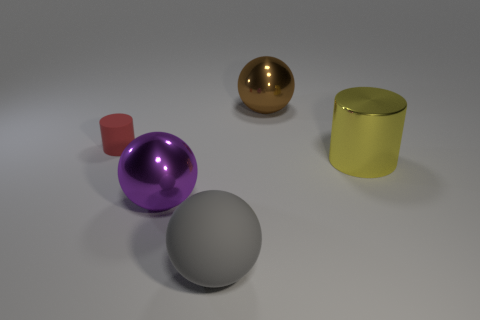What number of rubber things are either large brown objects or big blue cylinders?
Provide a succinct answer. 0. What number of objects are to the right of the purple shiny thing and behind the purple shiny ball?
Your answer should be compact. 2. Are there any other things that have the same shape as the tiny red matte object?
Your answer should be compact. Yes. How many other things are there of the same size as the brown ball?
Provide a succinct answer. 3. There is a cylinder that is right of the red matte cylinder; is it the same size as the thing that is to the left of the purple shiny sphere?
Your response must be concise. No. What number of objects are either tiny red cylinders or spheres that are in front of the red matte cylinder?
Offer a terse response. 3. How big is the metal object that is in front of the big yellow cylinder?
Offer a terse response. Large. Are there fewer large cylinders to the left of the gray matte object than yellow cylinders that are in front of the big purple metal thing?
Give a very brief answer. No. What is the big thing that is to the right of the gray sphere and in front of the brown shiny ball made of?
Your response must be concise. Metal. There is a big metal thing that is right of the big object that is behind the small rubber object; what shape is it?
Give a very brief answer. Cylinder. 